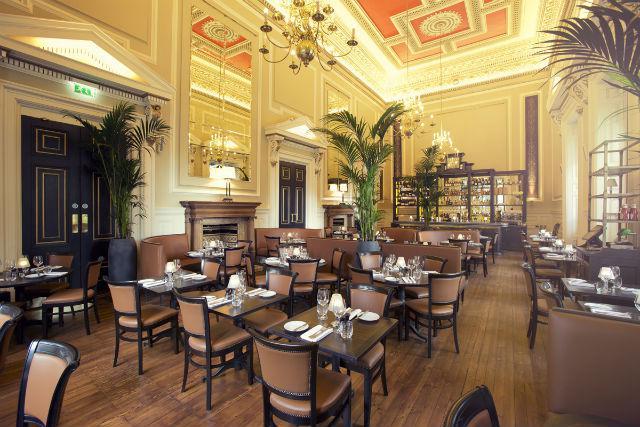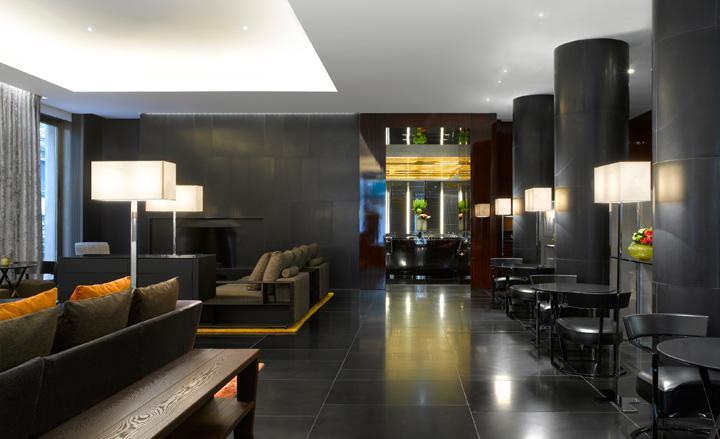The first image is the image on the left, the second image is the image on the right. Given the left and right images, does the statement "One restaurant interior features multiple cyclindrical black and red suspended lights over the seating area." hold true? Answer yes or no. No. The first image is the image on the left, the second image is the image on the right. Given the left and right images, does the statement "there is a painted tray ceiling with lighting hanging from it" hold true? Answer yes or no. Yes. 